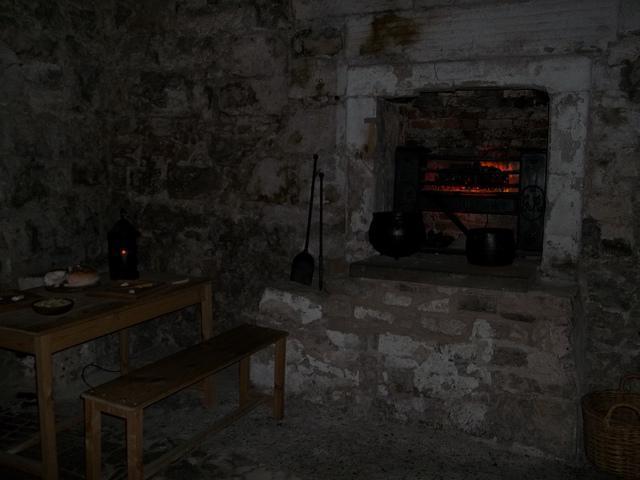How many dining tables are visible?
Give a very brief answer. 1. 